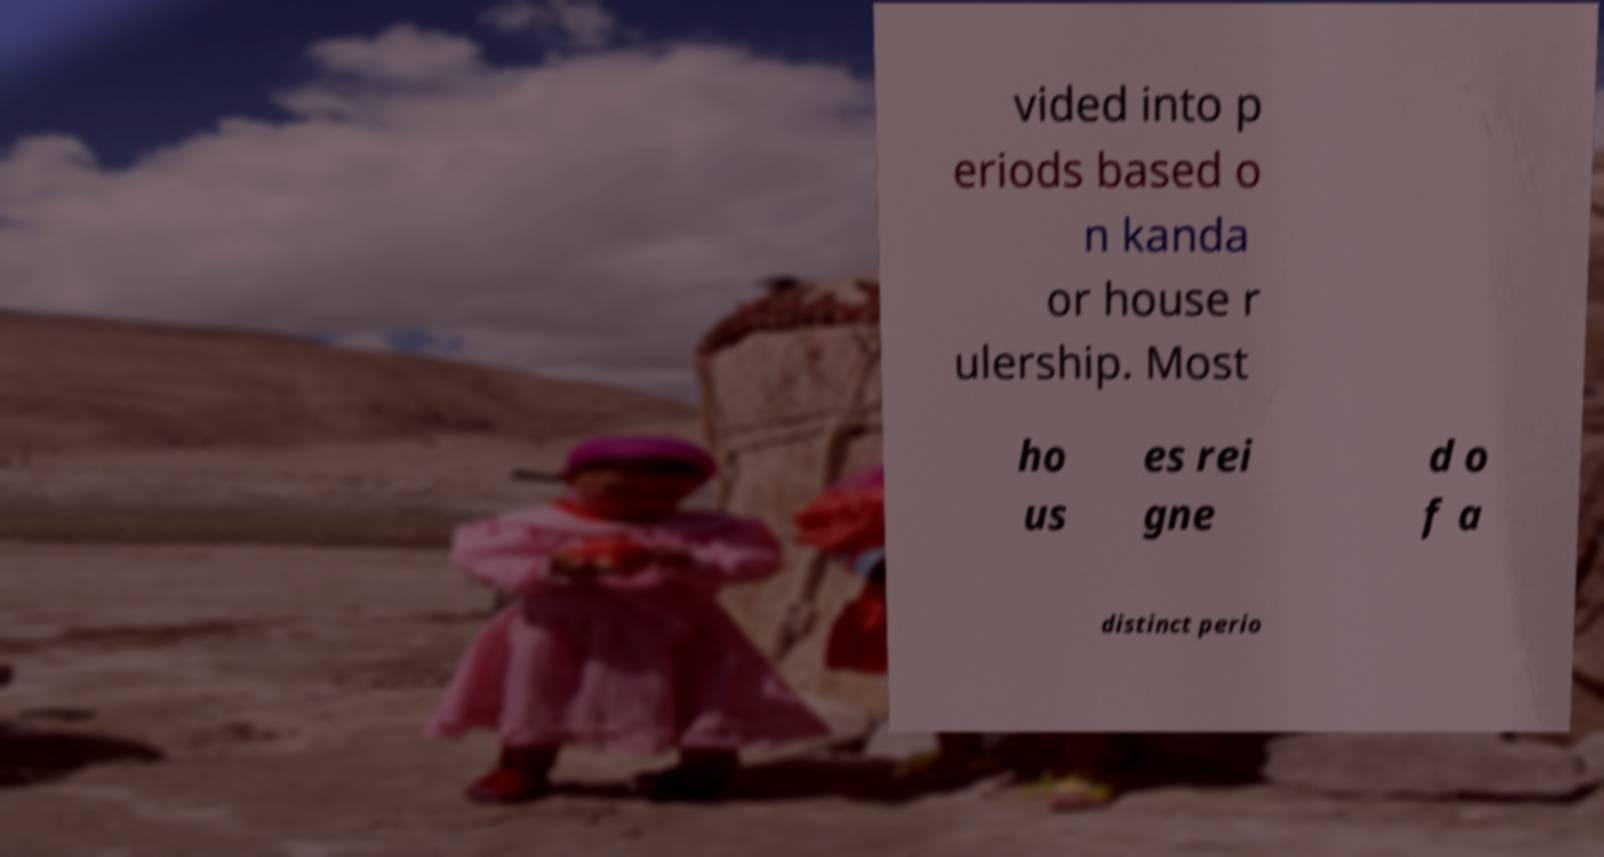For documentation purposes, I need the text within this image transcribed. Could you provide that? vided into p eriods based o n kanda or house r ulership. Most ho us es rei gne d o f a distinct perio 